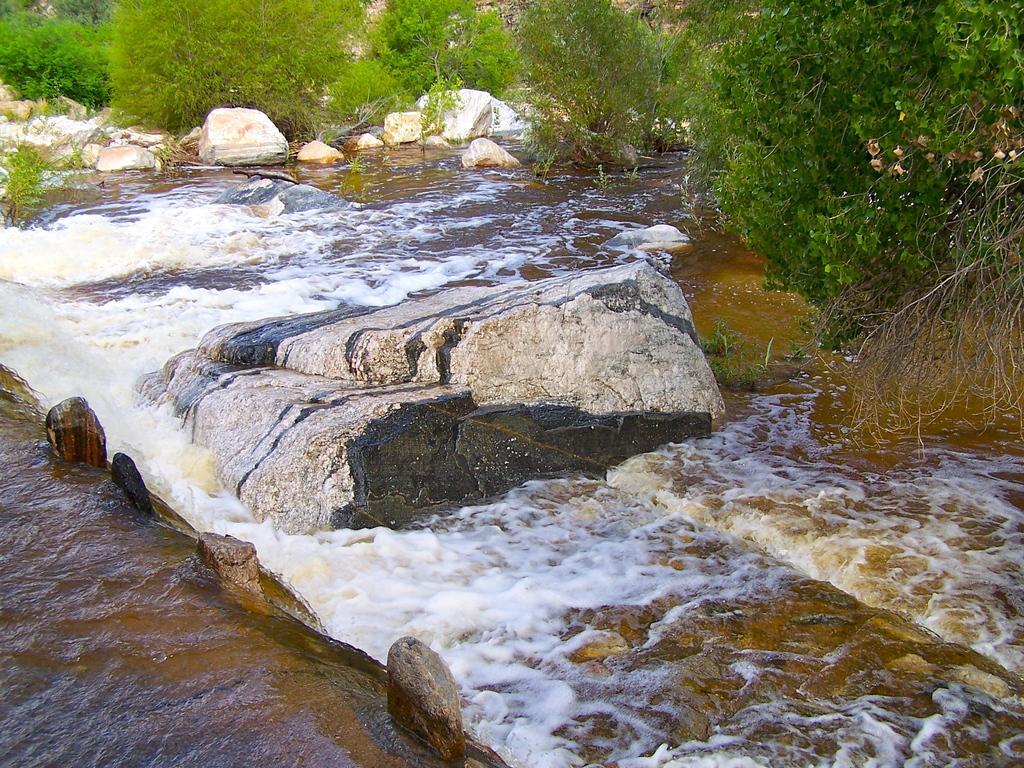In one or two sentences, can you explain what this image depicts? In this picture we can see water and some stones and in the background we can see trees. 